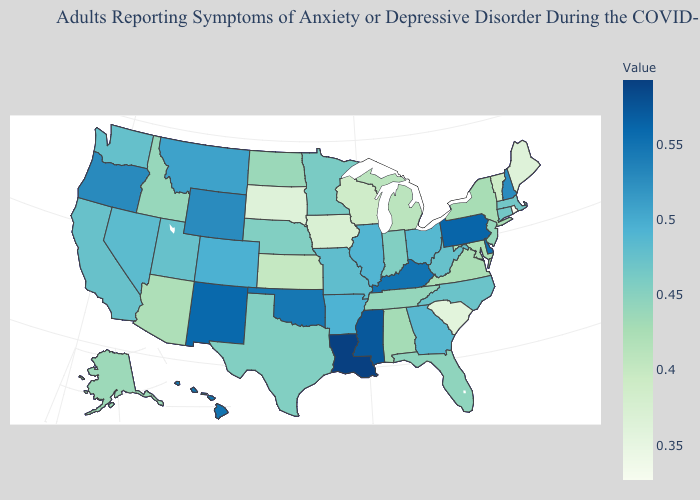Does Louisiana have the highest value in the USA?
Short answer required. Yes. Does Massachusetts have a higher value than Hawaii?
Give a very brief answer. No. Does North Dakota have the highest value in the USA?
Be succinct. No. Does Washington have a lower value than Louisiana?
Answer briefly. Yes. Does the map have missing data?
Be succinct. No. Does New York have a lower value than Vermont?
Keep it brief. No. Among the states that border Tennessee , which have the lowest value?
Answer briefly. Virginia. 